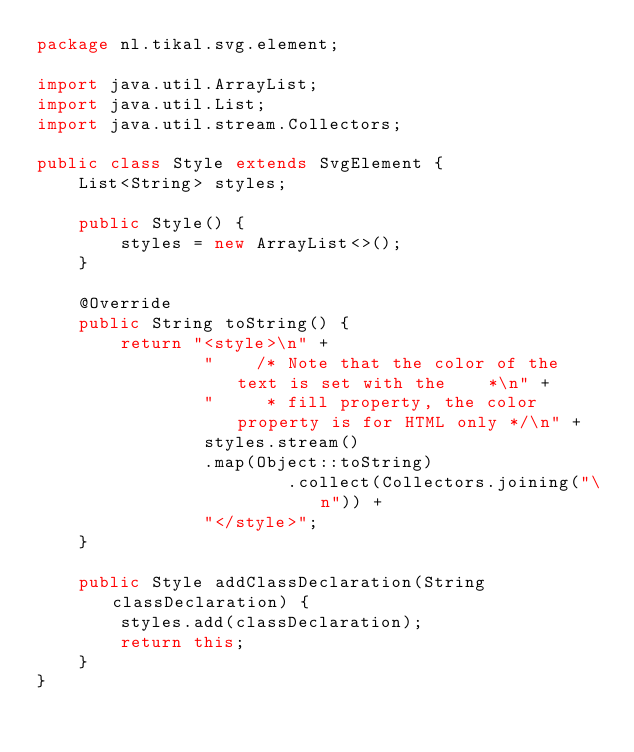Convert code to text. <code><loc_0><loc_0><loc_500><loc_500><_Java_>package nl.tikal.svg.element;

import java.util.ArrayList;
import java.util.List;
import java.util.stream.Collectors;

public class Style extends SvgElement {
    List<String> styles;

    public Style() {
        styles = new ArrayList<>();
    }

    @Override
    public String toString() {
        return "<style>\n" +
                "    /* Note that the color of the text is set with the    *\n" +
                "     * fill property, the color property is for HTML only */\n" +
                styles.stream()
                .map(Object::toString)
                        .collect(Collectors.joining("\n")) +
                "</style>";
    }

    public Style addClassDeclaration(String classDeclaration) {
        styles.add(classDeclaration);
        return this;
    }
}
</code> 